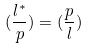Convert formula to latex. <formula><loc_0><loc_0><loc_500><loc_500>( \frac { l ^ { * } } { p } ) = ( \frac { p } { l } )</formula> 